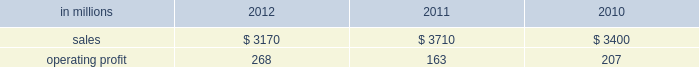Freesheet paper were higher in russia , but lower in europe reflecting weak economic conditions and market demand .
Average sales price realizations for pulp decreased .
Lower input costs for wood and purchased fiber were partially offset by higher costs for energy , chemicals and packaging .
Freight costs were also higher .
Planned maintenance downtime costs were higher due to executing a significant once-every-ten-years maintenance outage plus the regularly scheduled 18-month outage at the saillat mill while outage costs in russia and poland were lower .
Manufacturing operating costs were favor- entering 2013 , sales volumes in the first quarter are expected to be seasonally weaker in russia , but about flat in europe .
Average sales price realizations for uncoated freesheet paper are expected to decrease in europe , but increase in russia .
Input costs should be higher in russia , especially for wood and energy , but be slightly lower in europe .
No maintenance outages are scheduled for the first quarter .
Ind ian papers includes the results of andhra pradesh paper mills ( appm ) of which a 75% ( 75 % ) interest was acquired on october 14 , 2011 .
Net sales were $ 185 million in 2012 and $ 35 million in 2011 .
Operat- ing profits were a loss of $ 16 million in 2012 and a loss of $ 3 million in 2011 .
Asian pr int ing papers net sales were $ 85 mil- lion in 2012 , $ 75 million in 2011 and $ 80 million in 2010 .
Operating profits were improved from break- even in past years to $ 1 million in 2012 .
U.s .
Pulp net sales were $ 725 million in 2012 compared with $ 725 million in 2011 and $ 715 million in 2010 .
Operating profits were a loss of $ 59 million in 2012 compared with gains of $ 87 million in 2011 and $ 107 million in 2010 .
Sales volumes in 2012 increased from 2011 primarily due to the start-up of pulp production at the franklin mill in the third quarter of 2012 .
Average sales price realizations were significantly lower for both fluff pulp and market pulp .
Input costs were lower , primarily for wood and energy .
Freight costs were slightly lower .
Mill operating costs were unfavorable primarily due to costs associated with the start-up of the franklin mill .
Planned maintenance downtime costs were lower .
In the first quarter of 2013 , sales volumes are expected to be flat with the fourth quarter of 2012 .
Average sales price realizations are expected to improve reflecting the realization of sales price increases for paper and tissue pulp that were announced in the fourth quarter of 2012 .
Input costs should be flat .
Planned maintenance downtime costs should be about $ 9 million higher than in the fourth quarter of 2012 .
Manufacturing costs related to the franklin mill should be lower as we continue to improve operations .
Consumer packaging demand and pricing for consumer packaging prod- ucts correlate closely with consumer spending and general economic activity .
In addition to prices and volumes , major factors affecting the profitability of consumer packaging are raw material and energy costs , freight costs , manufacturing efficiency and product mix .
Consumer packaging net sales in 2012 decreased 15% ( 15 % ) from 2011 and 7% ( 7 % ) from 2010 .
Operating profits increased 64% ( 64 % ) from 2011 and 29% ( 29 % ) from 2010 .
Net sales and operating profits include the shorewood business in 2011 and 2010 .
Exclud- ing asset impairment and other charges associated with the sale of the shorewood business , and facility closure costs , 2012 operating profits were 27% ( 27 % ) lower than in 2011 , but 23% ( 23 % ) higher than in 2010 .
Benefits from lower raw material costs ( $ 22 million ) , lower maintenance outage costs ( $ 5 million ) and other items ( $ 2 million ) were more than offset by lower sales price realizations and an unfavorable product mix ( $ 66 million ) , lower sales volumes and increased market-related downtime ( $ 22 million ) , and higher operating costs ( $ 40 million ) .
In addition , operating profits in 2012 included a gain of $ 3 million related to the sale of the shorewood business while operating profits in 2011 included a $ 129 million fixed asset impairment charge for the north ameri- can shorewood business and $ 72 million for other charges associated with the sale of the shorewood business .
Consumer packaging .
North american consumer packaging net sales were $ 2.0 billion in 2012 compared with $ 2.5 billion in 2011 and $ 2.4 billion in 2010 .
Operating profits were $ 165 million ( $ 162 million excluding a gain related to the sale of the shorewood business ) in 2012 compared with $ 35 million ( $ 236 million excluding asset impairment and other charges asso- ciated with the sale of the shorewood business ) in 2011 and $ 97 million ( $ 105 million excluding facility closure costs ) in 2010 .
Coated paperboard sales volumes in 2012 were lower than in 2011 reflecting weaker market demand .
Average sales price realizations were lower , primar- ily for folding carton board .
Input costs for wood increased , but were partially offset by lower costs for chemicals and energy .
Planned maintenance down- time costs were slightly lower .
Market-related down- time was about 113000 tons in 2012 compared with about 38000 tons in 2011. .
What was the operating profit margin in 2012? 
Computations: (268 / 3170)
Answer: 0.08454. 